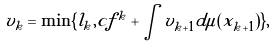<formula> <loc_0><loc_0><loc_500><loc_500>v _ { k } = \min \{ l _ { k } , c f ^ { k } + \int v _ { k + 1 } d \mu ( x _ { k + 1 } ) \} ,</formula> 